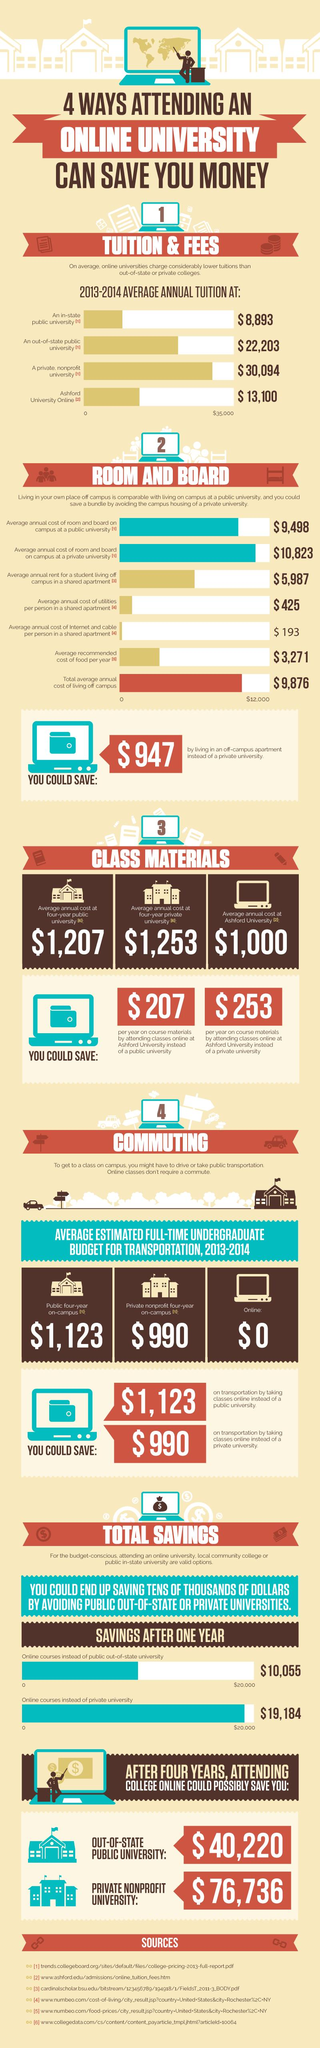Mention a couple of crucial points in this snapshot. The average annual cost for attending online classes at Ashford University is approximately $1,000. The average annual cost at a four-year public university is approximately $1,207. 